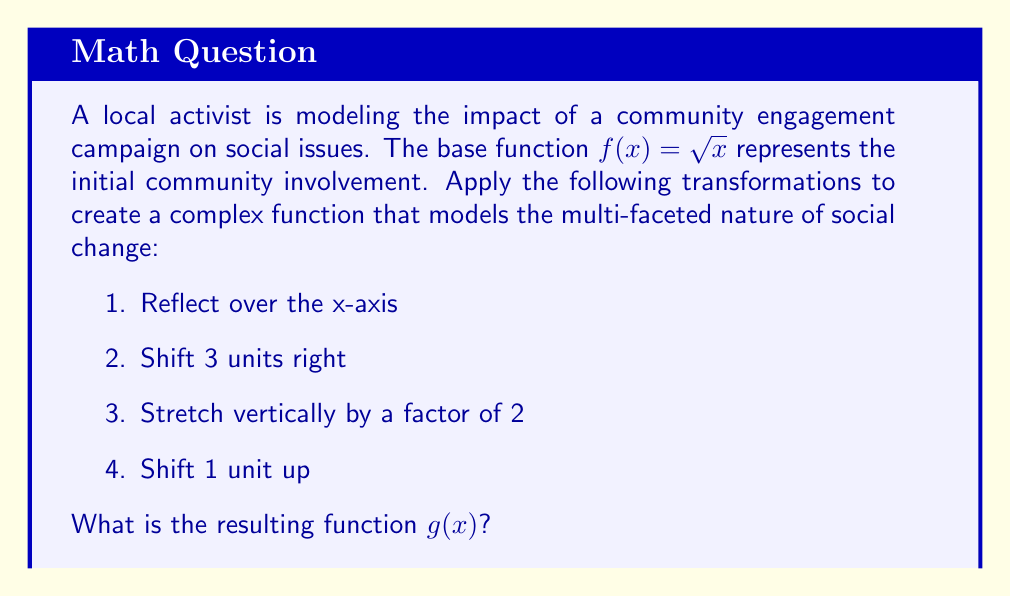What is the answer to this math problem? Let's apply the transformations step-by-step:

1. Reflect over the x-axis:
   $f_1(x) = -\sqrt{x}$

2. Shift 3 units right:
   $f_2(x) = -\sqrt{x-3}$

3. Stretch vertically by a factor of 2:
   $f_3(x) = -2\sqrt{x-3}$

4. Shift 1 unit up:
   $g(x) = -2\sqrt{x-3} + 1$

The resulting function $g(x)$ represents a complex model of community engagement, where:
- The reflection and vertical stretch represent the intensity of the campaign's impact.
- The horizontal shift represents a delay in seeing results.
- The vertical shift represents a baseline level of engagement.
Answer: $g(x) = -2\sqrt{x-3} + 1$ 